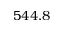<formula> <loc_0><loc_0><loc_500><loc_500>5 4 4 . 8</formula> 